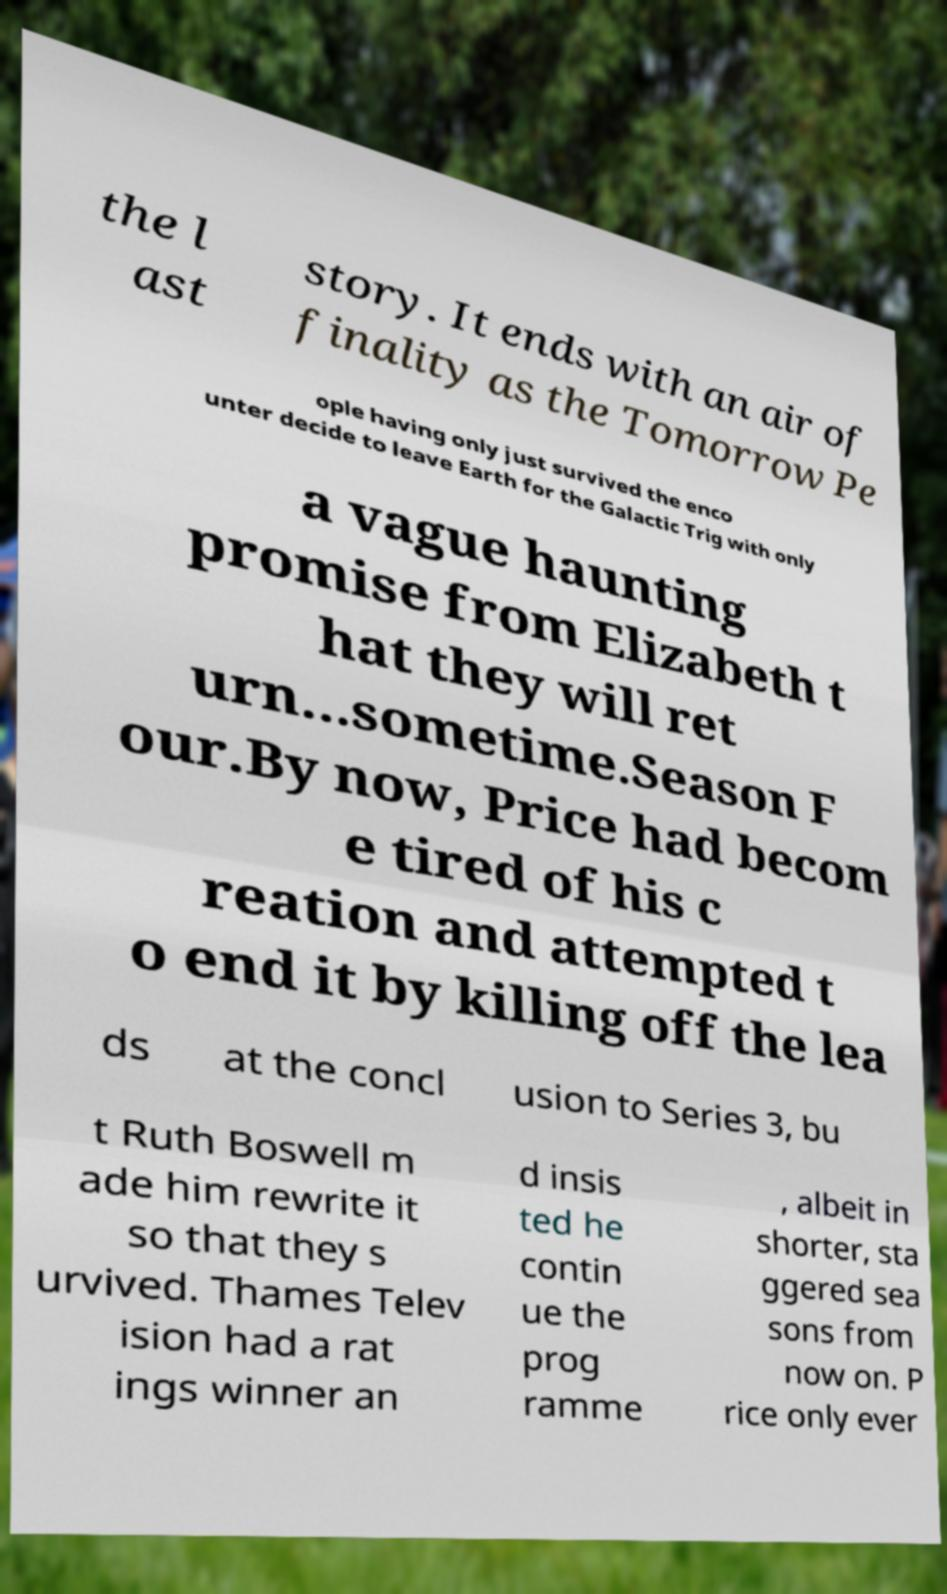Please identify and transcribe the text found in this image. the l ast story. It ends with an air of finality as the Tomorrow Pe ople having only just survived the enco unter decide to leave Earth for the Galactic Trig with only a vague haunting promise from Elizabeth t hat they will ret urn...sometime.Season F our.By now, Price had becom e tired of his c reation and attempted t o end it by killing off the lea ds at the concl usion to Series 3, bu t Ruth Boswell m ade him rewrite it so that they s urvived. Thames Telev ision had a rat ings winner an d insis ted he contin ue the prog ramme , albeit in shorter, sta ggered sea sons from now on. P rice only ever 